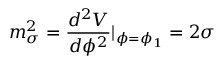Convert formula to latex. <formula><loc_0><loc_0><loc_500><loc_500>m _ { \sigma } ^ { 2 } = \frac { d ^ { 2 } V } { d \phi ^ { 2 } } | _ { \phi = \phi _ { 1 } } = 2 \sigma</formula> 